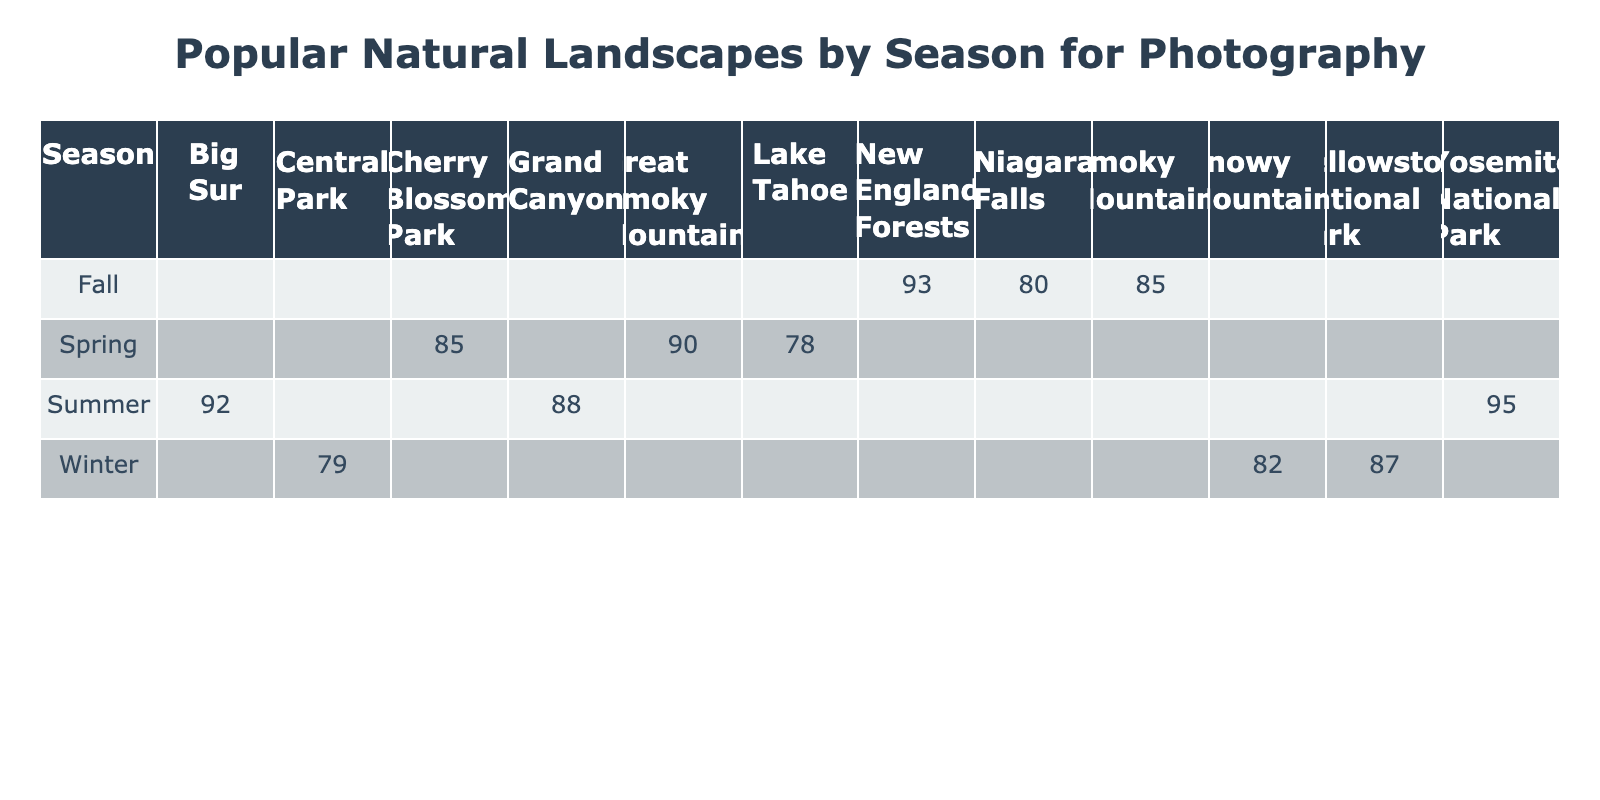What is the popularity score for Lake Tahoe in Spring? The table shows the popularity scores by landscape for each season. In the row for Spring, the column for Lake Tahoe indicates a popularity score of 78.
Answer: 78 Which natural landscape has the highest popularity score in Summer? Looking at the Summer row, we check the scores for each landscape—Yosemite National Park has 95, Grand Canyon has 88, and Big Sur has 92. The highest score is 95 for Yosemite National Park.
Answer: 95 Is the popularity score for Niagara Falls higher than that for Smoky Mountains in Fall? In the Fall row, Niagara Falls has a score of 80 while Smoky Mountains has a score of 85. Since 80 is less than 85, the popularity score for Niagara Falls is not higher than that for Smoky Mountains.
Answer: No What is the average popularity score for the landscapes in Winter? For Winter, the landscapes and their popularity scores are Yellowstone National Park (87), Snowy Mountains (82), and Central Park (79). Adding them gives 87 + 82 + 79 = 248. Dividing by the number of landscapes (3) gives an average of 248 / 3 = 82.67.
Answer: 82.67 Which season has the natural landscape with the lowest popularity score? To find this, we need to compare all the scores across seasons. The lowest score is for Central Park in Winter at 79. Therefore, Winter has the landscape with the lowest popularity score.
Answer: Winter What is the difference in popularity score between the highest and lowest landscape in Fall? In Fall, the scores are New England Forests (93), Niagara Falls (80), and Smoky Mountains (85). The highest score is 93 and the lowest is 80. The difference is 93 - 80 = 13.
Answer: 13 How many landscapes have a popularity score of 85 or higher in Spring? In Spring, the landscapes and their scores are Cherry Blossom Park (85), Lake Tahoe (78), and Great Smoky Mountains (90). Cherry Blossom Park and Great Smoky Mountains are 85 or higher, totaling 2 landscapes.
Answer: 2 Is there a landscape that has the same popularity score in more than one season? Checking the scores, there is no repetition; each landscape has a unique score in its specific season. Therefore, no landscapes have the same popularity score across seasons.
Answer: No What is the total popularity score for all landscapes in Summer? The landscapes and scores in Summer are Yosemite National Park (95), Grand Canyon (88), and Big Sur (92). Summing these gives 95 + 88 + 92 = 275.
Answer: 275 